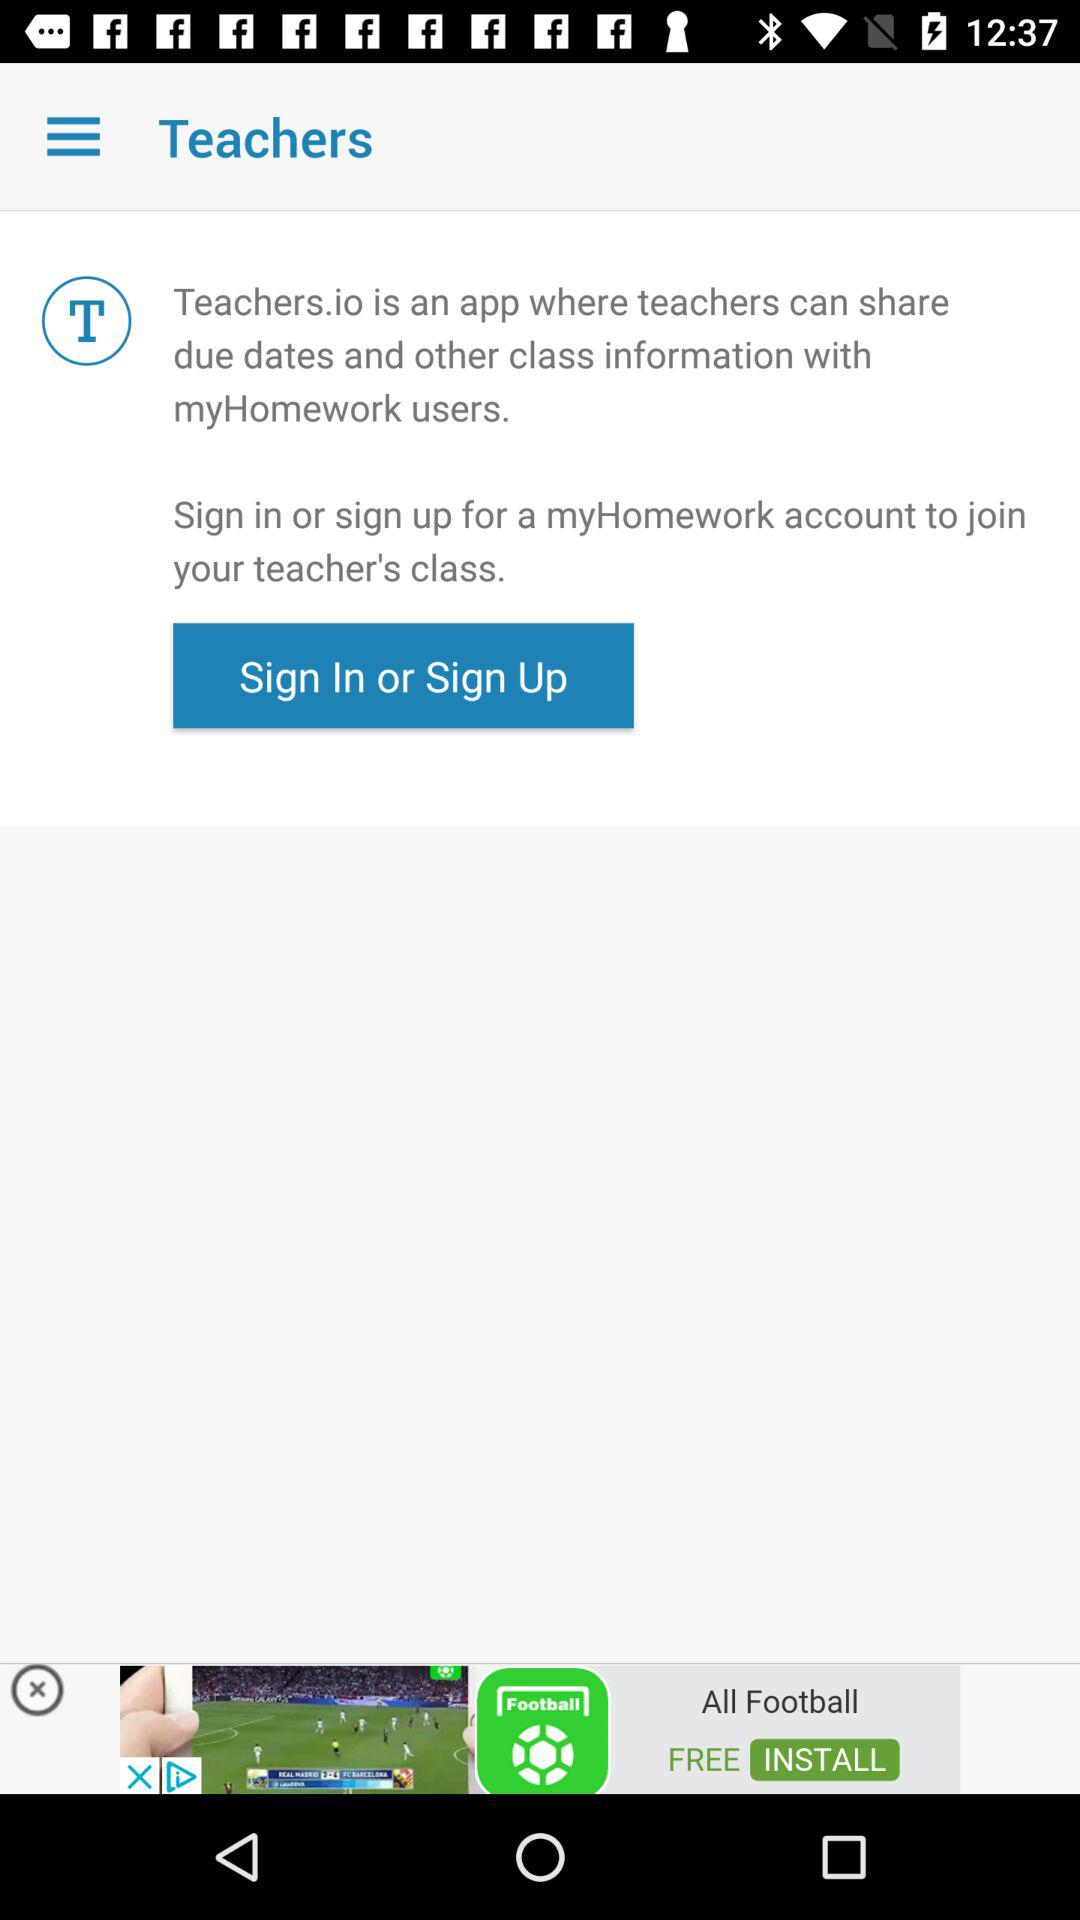What is the name of the application? The name of the application is "Teachers.io". 